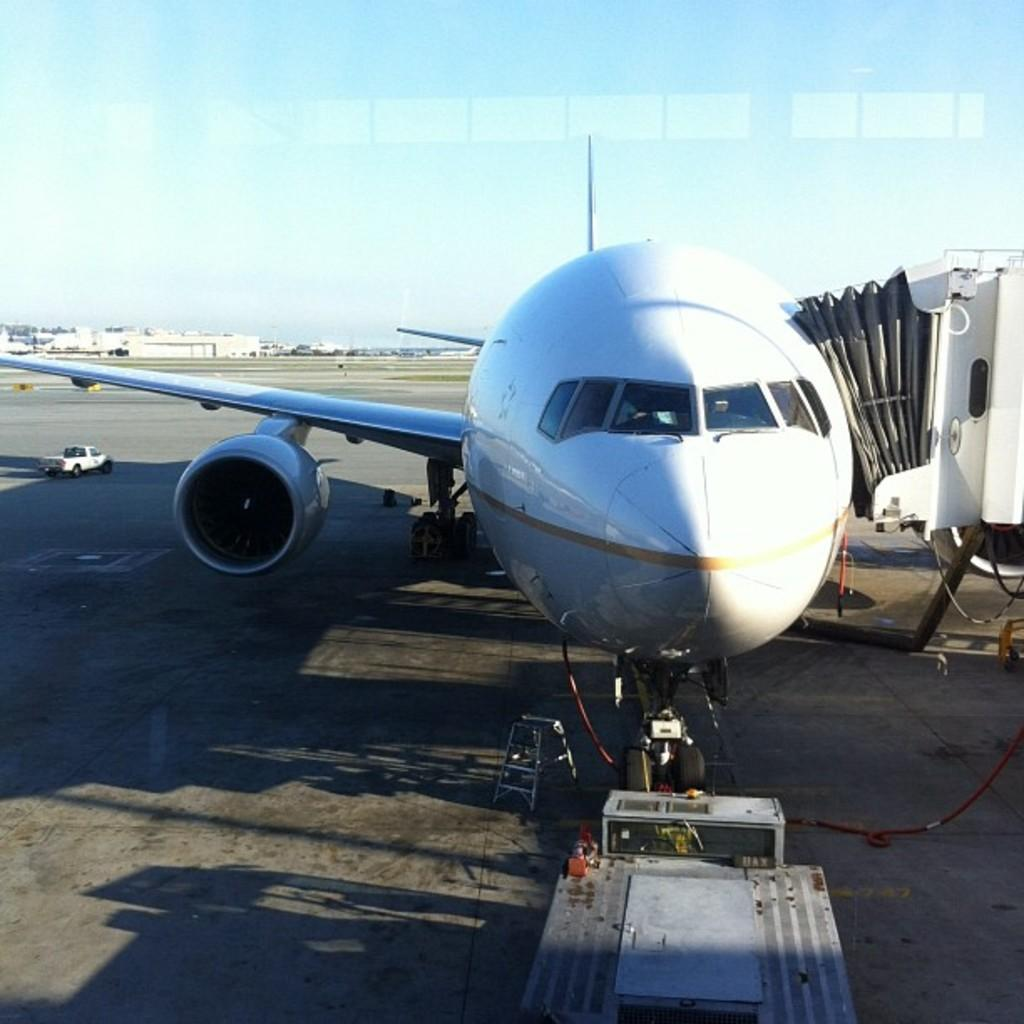What is the main subject of the image? The main subject of the image is an airplane. What other objects can be seen in the image? There is a vehicle and a stand in the image. What is on the surface in the image? There are objects on the surface in the image. What can be seen in the background of the image? There are buildings and the sky visible in the background of the image. How does the pear increase in size in the image? There is no pear present in the image, so it cannot increase in size. 